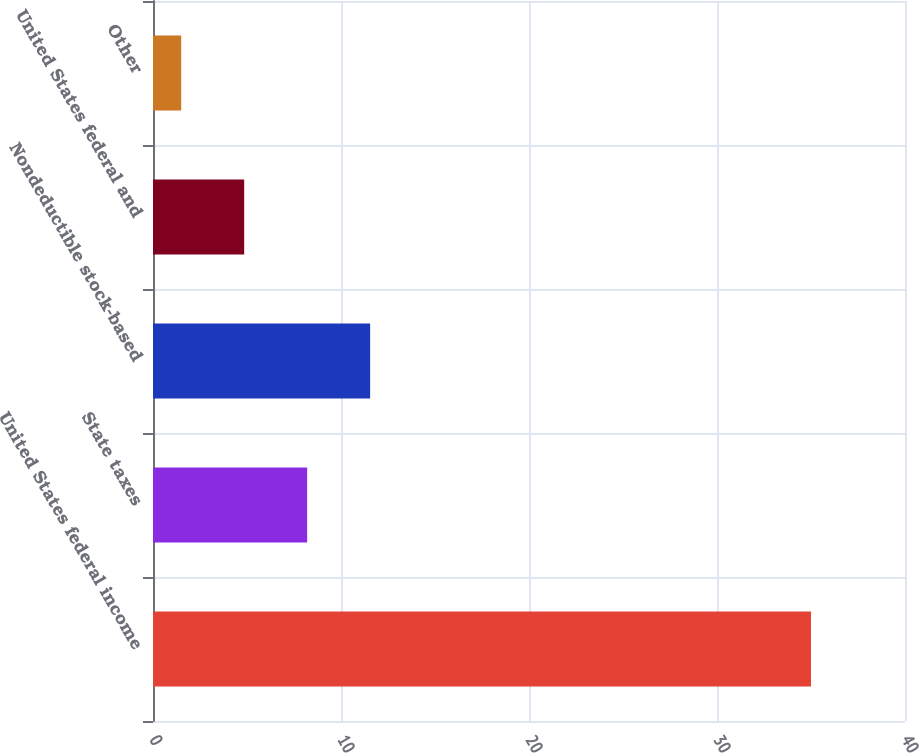Convert chart. <chart><loc_0><loc_0><loc_500><loc_500><bar_chart><fcel>United States federal income<fcel>State taxes<fcel>Nondeductible stock-based<fcel>United States federal and<fcel>Other<nl><fcel>35<fcel>8.2<fcel>11.55<fcel>4.85<fcel>1.5<nl></chart> 